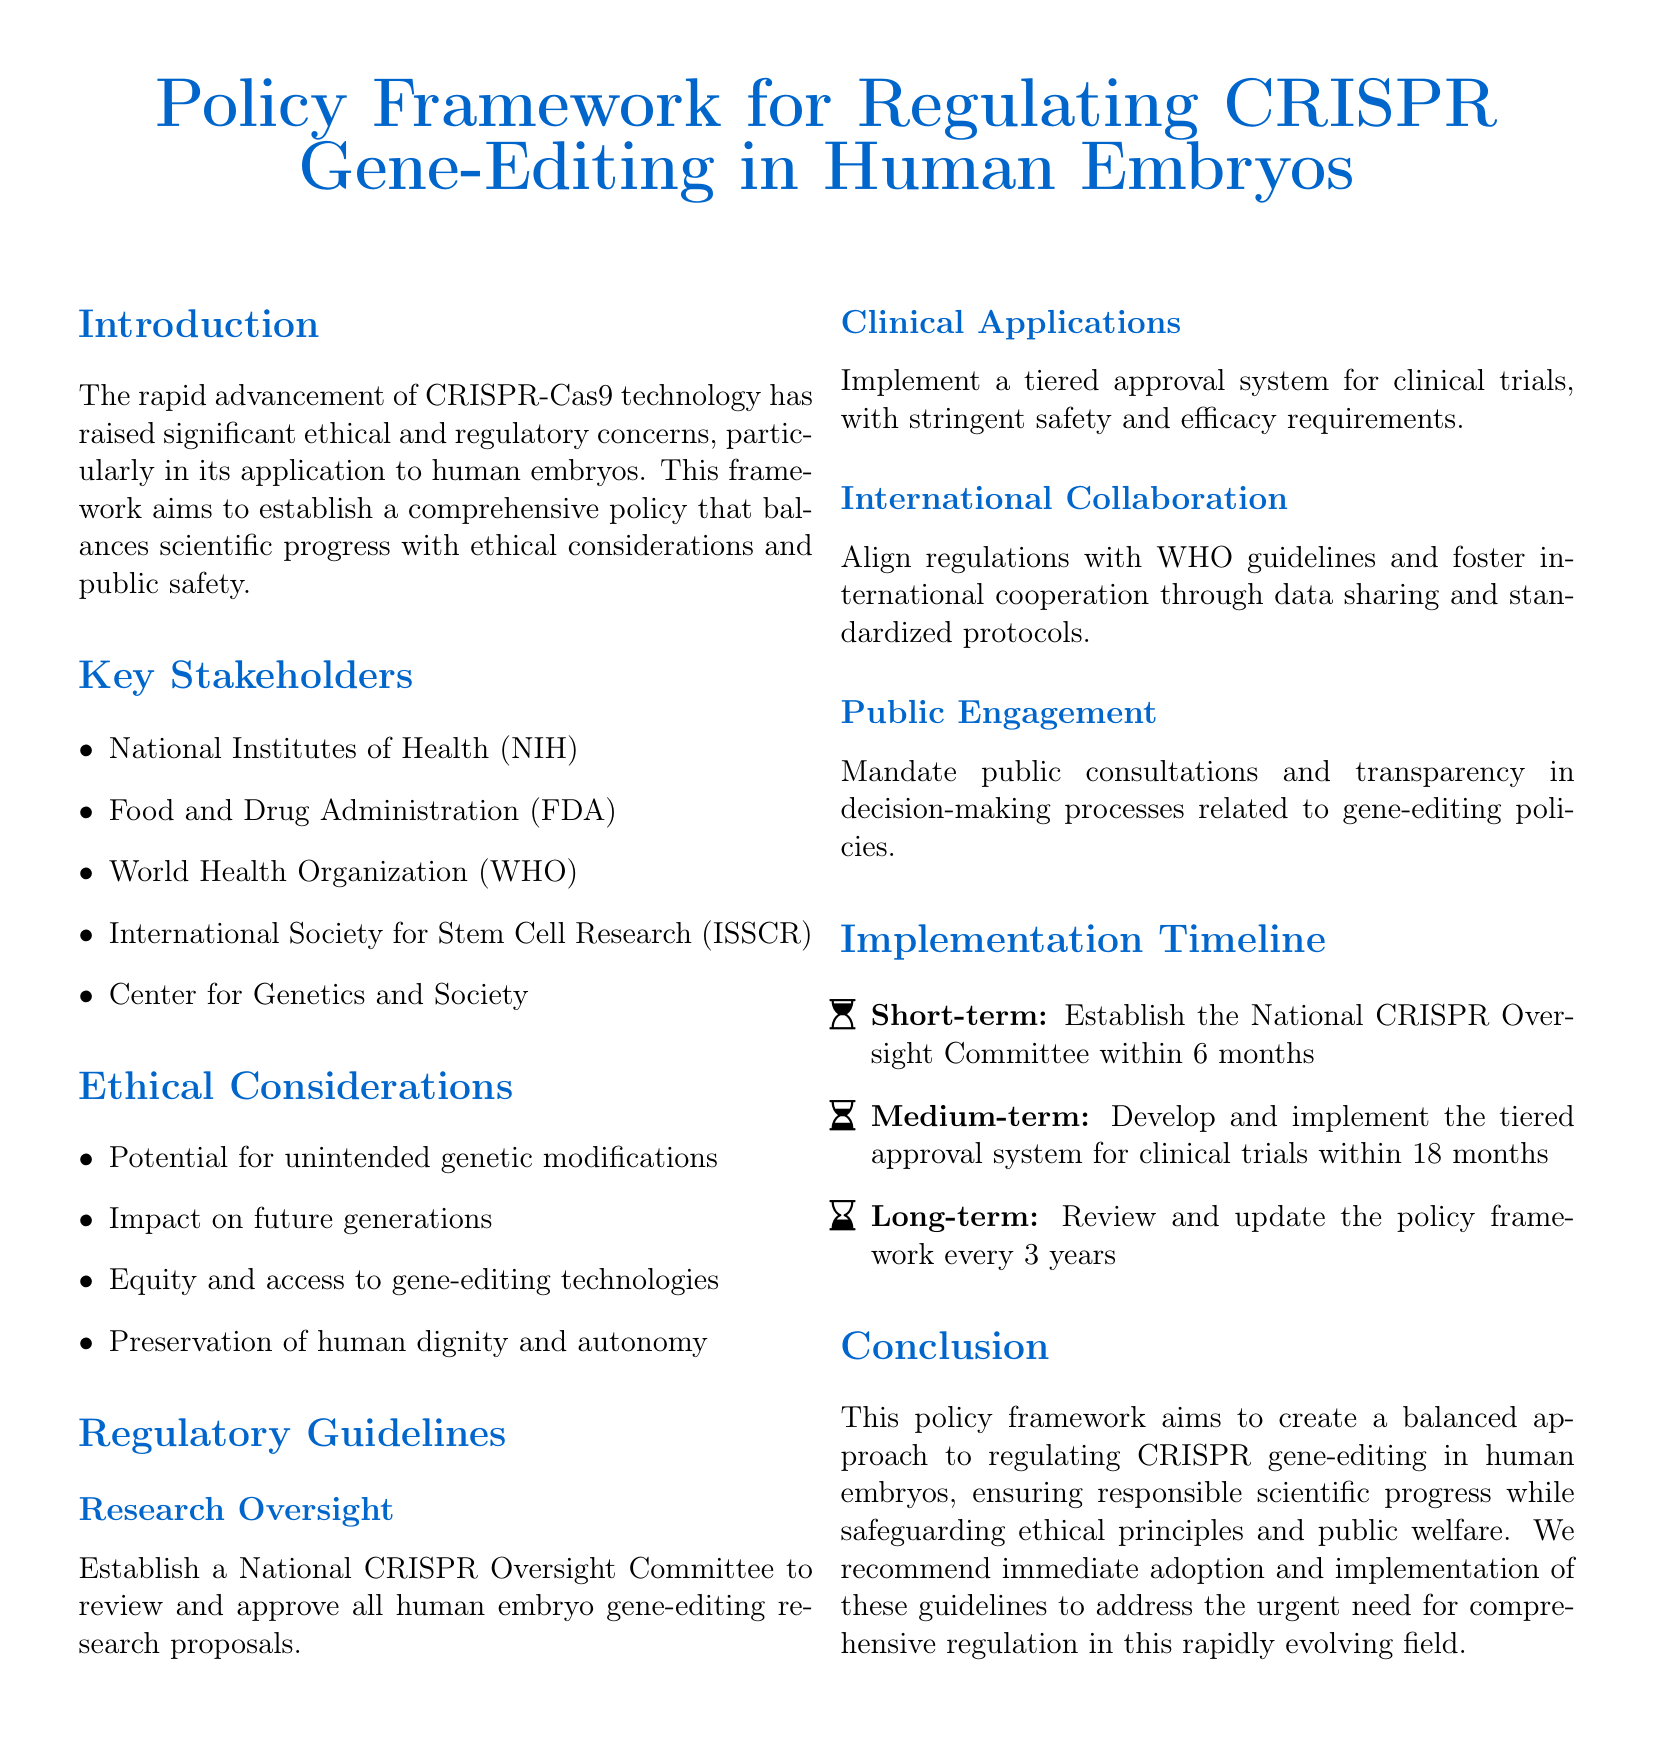What is the title of the document? The title is prominently displayed at the top of the document.
Answer: Policy Framework for Regulating CRISPR Gene-Editing in Human Embryos Who is responsible for establishing the National CRISPR Oversight Committee? The document outlines that research oversight will be handled at the national level.
Answer: National Institutes of Health What is the purpose of the tiered approval system? The system is mentioned in the regulatory guidelines section as part of clinical applications.
Answer: Safety and efficacy requirements What is one ethical consideration mentioned in the document? Ethical considerations are listed in a specific section of the framework.
Answer: Potential for unintended genetic modifications How often should the policy framework be reviewed and updated? The implementation timeline specifies the frequency of reviews.
Answer: Every 3 years Which organization is suggested for international collaboration? The document references this organization's guidelines for alignment with regulations.
Answer: World Health Organization What is the short-term goal for establishing the oversight committee? The timeline describes a specific duration for this establishment.
Answer: 6 months What does the document recommend for public engagement? A section discusses strategies for involving the public in decision-making.
Answer: Public consultations What is the medium-term goal for clinical trials? The timeline outlines a specific timeframe for developing the approval system.
Answer: 18 months 